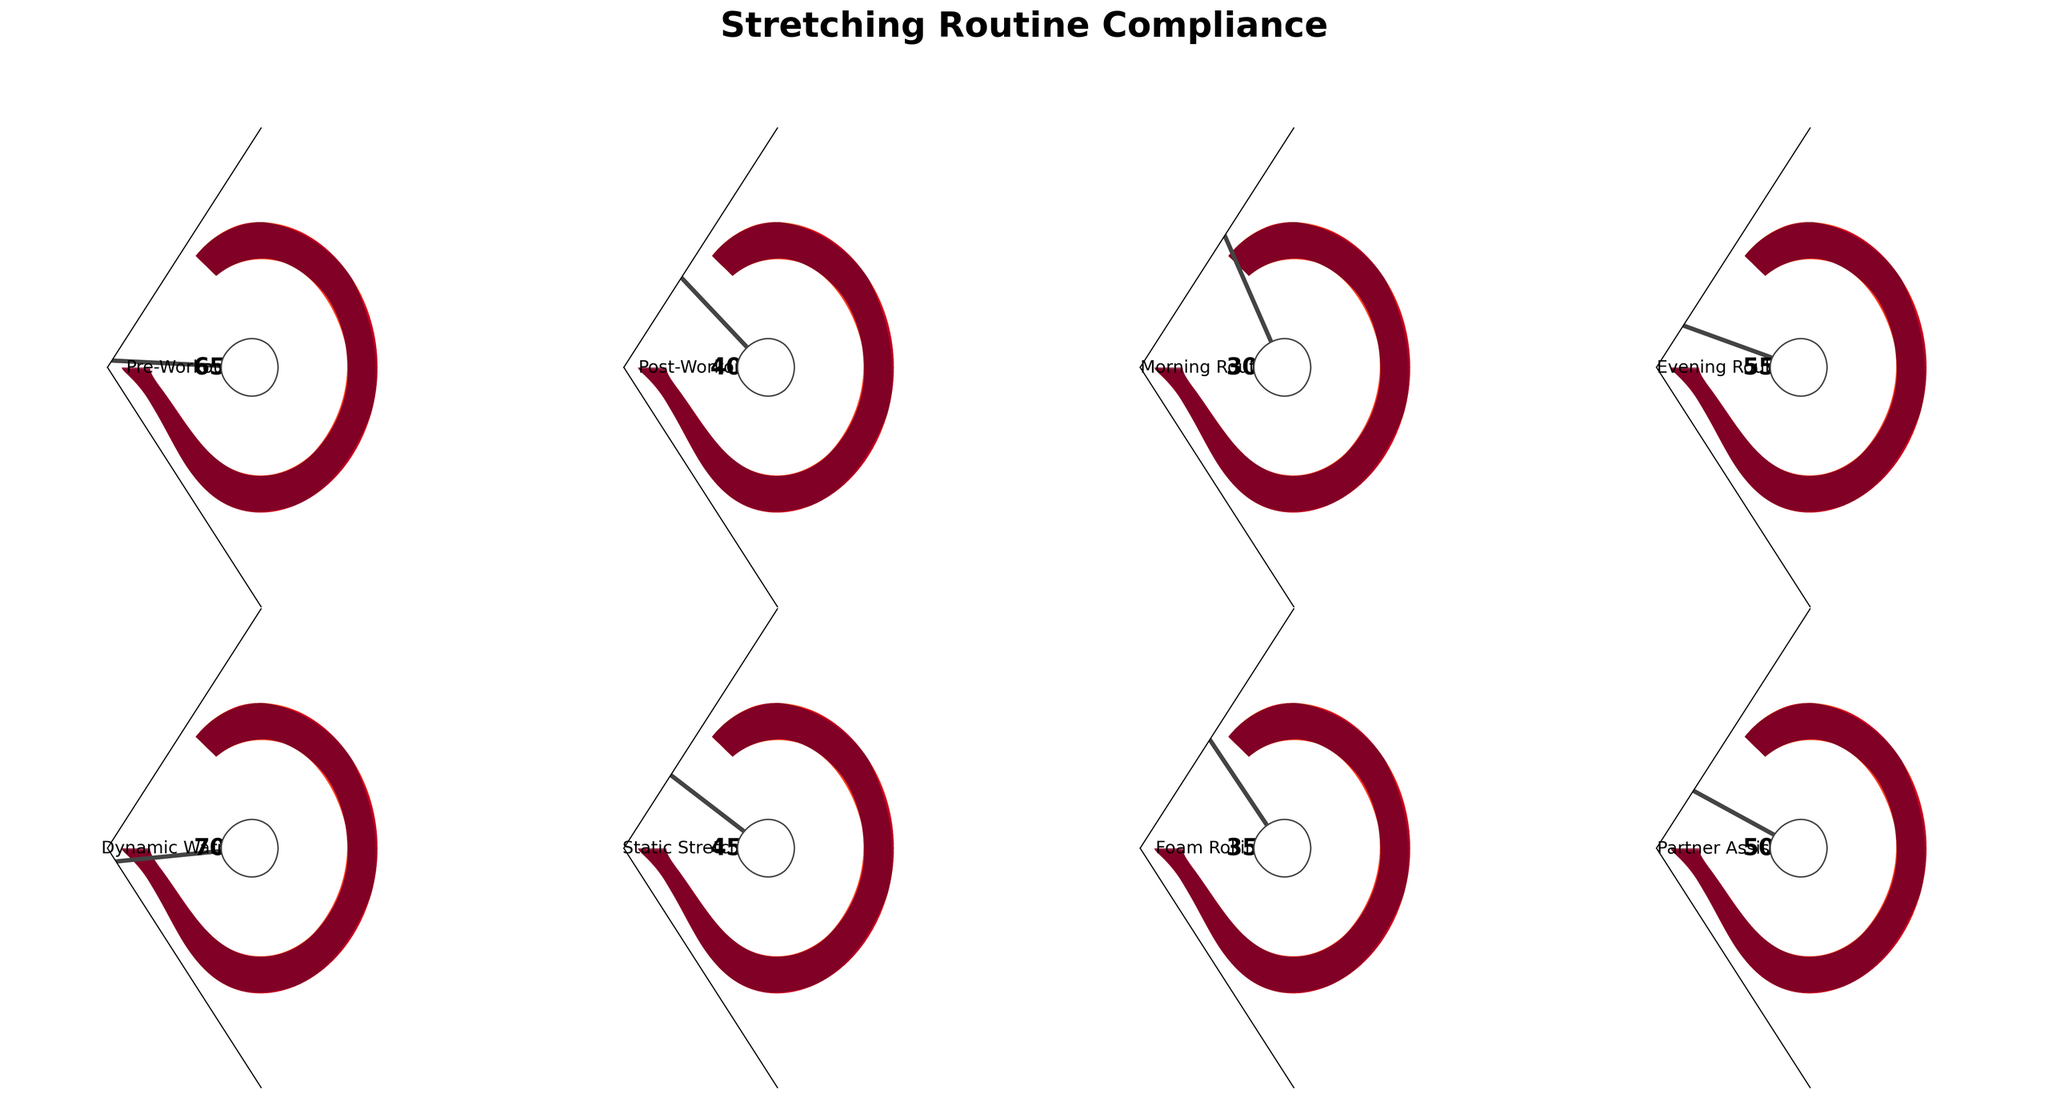What's the compliance percentage for Pre-Workout stretching? The gauge chart for Pre-Workout stretching has the needle pointing at the 65% mark.
Answer: 65% What's the difference in compliance percentages between Post-Workout and Foam Rolling stretching routines? Post-Workout compliance is at 40%, while Foam Rolling is at 35%. The difference is 40% - 35% = 5%.
Answer: 5% Which stretching type has the highest compliance percentage? Among all the stretching types, Dynamic Warmup has the highest compliance at 70%.
Answer: Dynamic Warmup Which stretching type has the lowest compliance percentage? Among all the stretching types, Morning Routine has the lowest compliance at 30%.
Answer: Morning Routine What's the average compliance percentage across all stretching types? The compliance percentages are 65, 40, 30, 55, 70, 45, 35, 50. Summing these equals 390. The number of types is 8. So, the average is 390 / 8 = 48.75.
Answer: 48.75 How does the compliance for Static Stretching compare to Partner Assisted Stretching? Static Stretching compliance is 45% and Partner Assisted compliance is 50%. Static Stretching's compliance is 5% lower than Partner Assisted.
Answer: Static Stretching is 5% lower What is the median compliance percentage of the routines? Ordering percentages: 30, 35, 40, 45, 50, 55, 65, 70. The median is (45 + 50) / 2 = 47.5.
Answer: 47.5 Which stretching routines have compliance percentages above 50%? Routines with compliance above 50% are Pre-Workout (65%), Evening Routine (55%), and Dynamic Warmup (70%).
Answer: Pre-Workout, Evening Routine, Dynamic Warmup What is the compliance percentage for Evening Routine stretching? The gauge chart for Evening Routine stretching shows the needle pointing at the 55% mark.
Answer: 55% What is the combined compliance percentage for both morning and evening routines? Morning Routine compliance is 30%, Evening Routine is 55%. The combined compliance is 30 + 55 = 85%.
Answer: 85% 